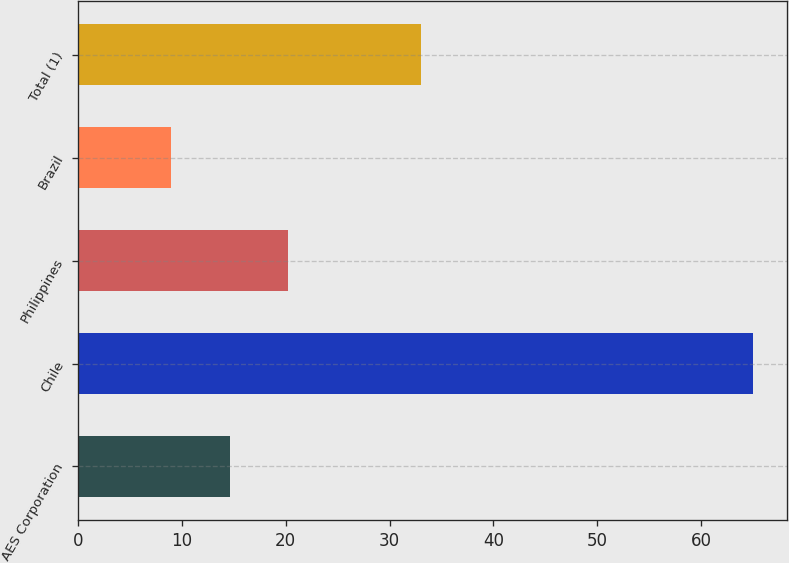Convert chart to OTSL. <chart><loc_0><loc_0><loc_500><loc_500><bar_chart><fcel>AES Corporation<fcel>Chile<fcel>Philippines<fcel>Brazil<fcel>Total (1)<nl><fcel>14.6<fcel>65<fcel>20.2<fcel>9<fcel>33<nl></chart> 